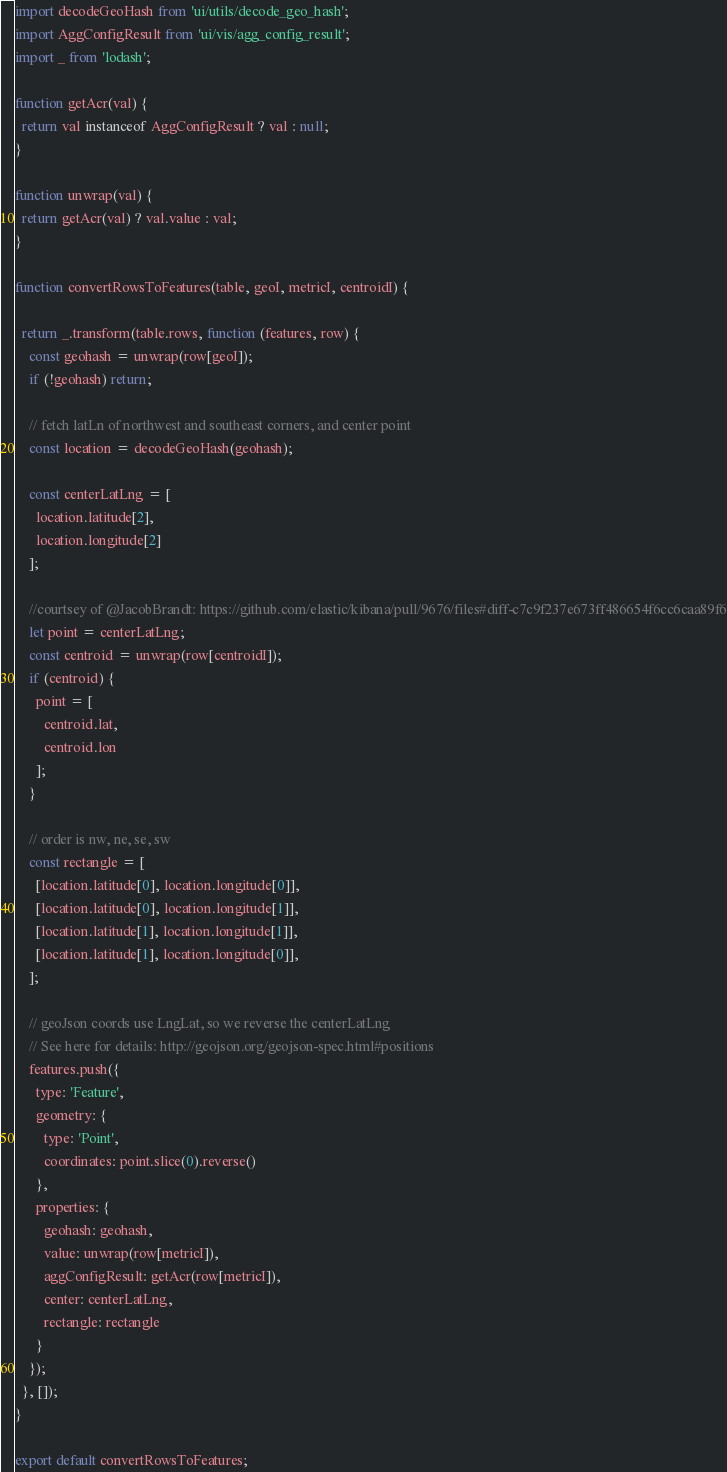Convert code to text. <code><loc_0><loc_0><loc_500><loc_500><_JavaScript_>import decodeGeoHash from 'ui/utils/decode_geo_hash';
import AggConfigResult from 'ui/vis/agg_config_result';
import _ from 'lodash';

function getAcr(val) {
  return val instanceof AggConfigResult ? val : null;
}

function unwrap(val) {
  return getAcr(val) ? val.value : val;
}

function convertRowsToFeatures(table, geoI, metricI, centroidI) {

  return _.transform(table.rows, function (features, row) {
    const geohash = unwrap(row[geoI]);
    if (!geohash) return;

    // fetch latLn of northwest and southeast corners, and center point
    const location = decodeGeoHash(geohash);

    const centerLatLng = [
      location.latitude[2],
      location.longitude[2]
    ];

    //courtsey of @JacobBrandt: https://github.com/elastic/kibana/pull/9676/files#diff-c7c9f237e673ff486654f6cc6caa89f6
    let point = centerLatLng;
    const centroid = unwrap(row[centroidI]);
    if (centroid) {
      point = [
        centroid.lat,
        centroid.lon
      ];
    }

    // order is nw, ne, se, sw
    const rectangle = [
      [location.latitude[0], location.longitude[0]],
      [location.latitude[0], location.longitude[1]],
      [location.latitude[1], location.longitude[1]],
      [location.latitude[1], location.longitude[0]],
    ];

    // geoJson coords use LngLat, so we reverse the centerLatLng
    // See here for details: http://geojson.org/geojson-spec.html#positions
    features.push({
      type: 'Feature',
      geometry: {
        type: 'Point',
        coordinates: point.slice(0).reverse()
      },
      properties: {
        geohash: geohash,
        value: unwrap(row[metricI]),
        aggConfigResult: getAcr(row[metricI]),
        center: centerLatLng,
        rectangle: rectangle
      }
    });
  }, []);
}

export default convertRowsToFeatures;
</code> 